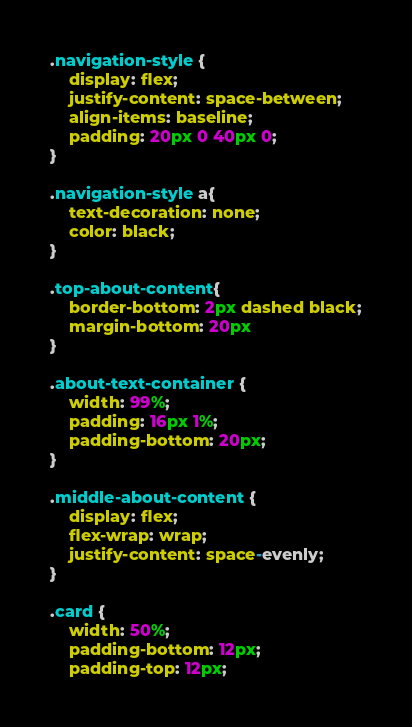<code> <loc_0><loc_0><loc_500><loc_500><_CSS_>.navigation-style {
    display: flex;
    justify-content: space-between;
    align-items: baseline;
    padding: 20px 0 40px 0;
}

.navigation-style a{
    text-decoration: none;
    color: black;
}

.top-about-content{
    border-bottom: 2px dashed black;
    margin-bottom: 20px
}

.about-text-container {
    width: 99%;
    padding: 16px 1%;
    padding-bottom: 20px;
}

.middle-about-content {
    display: flex;
    flex-wrap: wrap;
    justify-content: space-evenly;
}

.card {
    width: 50%;
    padding-bottom: 12px;
    padding-top: 12px;</code> 